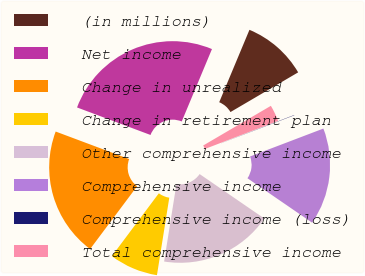Convert chart to OTSL. <chart><loc_0><loc_0><loc_500><loc_500><pie_chart><fcel>(in millions)<fcel>Net income<fcel>Change in unrealized<fcel>Change in retirement plan<fcel>Other comprehensive income<fcel>Comprehensive income<fcel>Comprehensive income (loss)<fcel>Total comprehensive income<nl><fcel>10.26%<fcel>25.59%<fcel>20.48%<fcel>7.71%<fcel>17.93%<fcel>15.37%<fcel>0.05%<fcel>2.6%<nl></chart> 